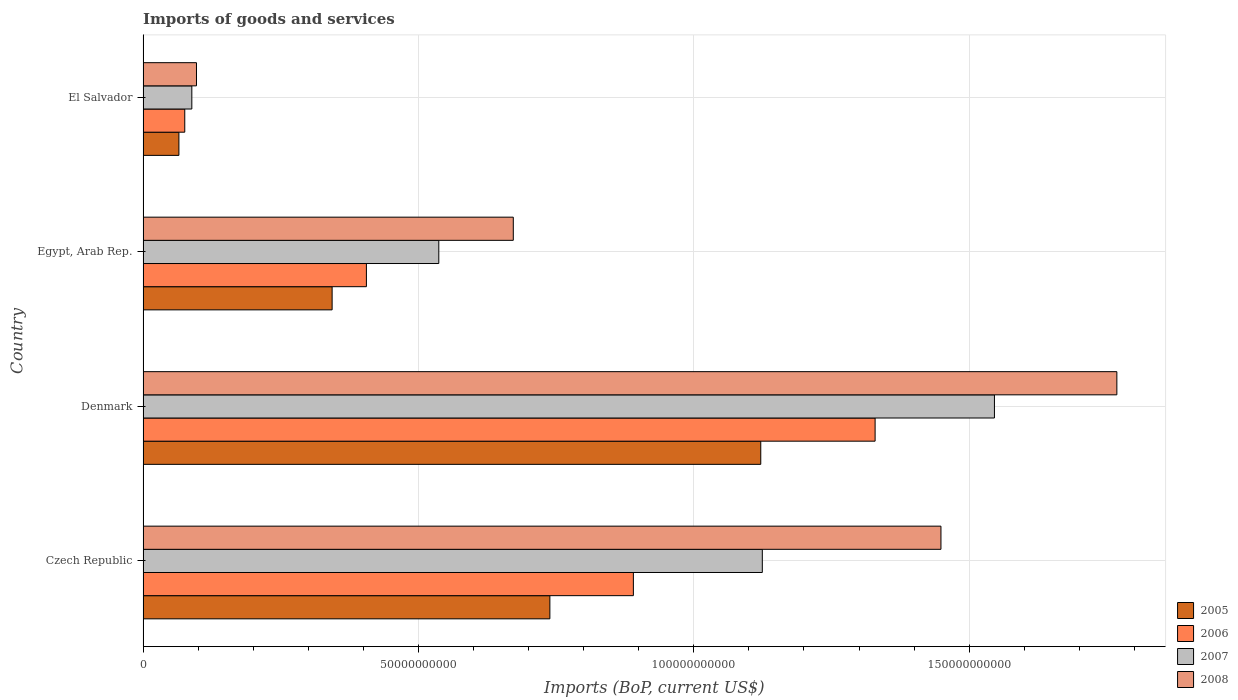How many different coloured bars are there?
Your answer should be compact. 4. Are the number of bars per tick equal to the number of legend labels?
Provide a short and direct response. Yes. Are the number of bars on each tick of the Y-axis equal?
Provide a short and direct response. Yes. How many bars are there on the 4th tick from the top?
Your answer should be compact. 4. How many bars are there on the 4th tick from the bottom?
Ensure brevity in your answer.  4. What is the label of the 1st group of bars from the top?
Give a very brief answer. El Salvador. What is the amount spent on imports in 2008 in Egypt, Arab Rep.?
Ensure brevity in your answer.  6.72e+1. Across all countries, what is the maximum amount spent on imports in 2007?
Your response must be concise. 1.55e+11. Across all countries, what is the minimum amount spent on imports in 2007?
Offer a very short reply. 8.86e+09. In which country was the amount spent on imports in 2008 minimum?
Give a very brief answer. El Salvador. What is the total amount spent on imports in 2006 in the graph?
Offer a very short reply. 2.70e+11. What is the difference between the amount spent on imports in 2007 in Egypt, Arab Rep. and that in El Salvador?
Provide a succinct answer. 4.48e+1. What is the difference between the amount spent on imports in 2007 in Czech Republic and the amount spent on imports in 2008 in Denmark?
Ensure brevity in your answer.  -6.44e+1. What is the average amount spent on imports in 2007 per country?
Provide a short and direct response. 8.24e+1. What is the difference between the amount spent on imports in 2007 and amount spent on imports in 2008 in Czech Republic?
Your answer should be compact. -3.24e+1. In how many countries, is the amount spent on imports in 2006 greater than 160000000000 US$?
Provide a succinct answer. 0. What is the ratio of the amount spent on imports in 2008 in Denmark to that in Egypt, Arab Rep.?
Provide a succinct answer. 2.63. Is the amount spent on imports in 2005 in Czech Republic less than that in Denmark?
Your answer should be compact. Yes. Is the difference between the amount spent on imports in 2007 in Egypt, Arab Rep. and El Salvador greater than the difference between the amount spent on imports in 2008 in Egypt, Arab Rep. and El Salvador?
Provide a succinct answer. No. What is the difference between the highest and the second highest amount spent on imports in 2005?
Your response must be concise. 3.83e+1. What is the difference between the highest and the lowest amount spent on imports in 2007?
Keep it short and to the point. 1.46e+11. In how many countries, is the amount spent on imports in 2006 greater than the average amount spent on imports in 2006 taken over all countries?
Give a very brief answer. 2. Is it the case that in every country, the sum of the amount spent on imports in 2007 and amount spent on imports in 2008 is greater than the sum of amount spent on imports in 2006 and amount spent on imports in 2005?
Ensure brevity in your answer.  No. What does the 2nd bar from the top in Egypt, Arab Rep. represents?
Ensure brevity in your answer.  2007. Is it the case that in every country, the sum of the amount spent on imports in 2006 and amount spent on imports in 2008 is greater than the amount spent on imports in 2005?
Offer a very short reply. Yes. How many bars are there?
Make the answer very short. 16. What is the difference between two consecutive major ticks on the X-axis?
Give a very brief answer. 5.00e+1. Are the values on the major ticks of X-axis written in scientific E-notation?
Ensure brevity in your answer.  No. Does the graph contain any zero values?
Offer a terse response. No. How many legend labels are there?
Keep it short and to the point. 4. What is the title of the graph?
Offer a very short reply. Imports of goods and services. What is the label or title of the X-axis?
Offer a very short reply. Imports (BoP, current US$). What is the label or title of the Y-axis?
Provide a succinct answer. Country. What is the Imports (BoP, current US$) in 2005 in Czech Republic?
Your answer should be compact. 7.39e+1. What is the Imports (BoP, current US$) of 2006 in Czech Republic?
Offer a very short reply. 8.90e+1. What is the Imports (BoP, current US$) in 2007 in Czech Republic?
Give a very brief answer. 1.12e+11. What is the Imports (BoP, current US$) in 2008 in Czech Republic?
Your response must be concise. 1.45e+11. What is the Imports (BoP, current US$) of 2005 in Denmark?
Your answer should be very brief. 1.12e+11. What is the Imports (BoP, current US$) of 2006 in Denmark?
Provide a short and direct response. 1.33e+11. What is the Imports (BoP, current US$) in 2007 in Denmark?
Offer a very short reply. 1.55e+11. What is the Imports (BoP, current US$) of 2008 in Denmark?
Offer a very short reply. 1.77e+11. What is the Imports (BoP, current US$) of 2005 in Egypt, Arab Rep.?
Provide a short and direct response. 3.43e+1. What is the Imports (BoP, current US$) of 2006 in Egypt, Arab Rep.?
Give a very brief answer. 4.06e+1. What is the Imports (BoP, current US$) in 2007 in Egypt, Arab Rep.?
Give a very brief answer. 5.37e+1. What is the Imports (BoP, current US$) of 2008 in Egypt, Arab Rep.?
Ensure brevity in your answer.  6.72e+1. What is the Imports (BoP, current US$) in 2005 in El Salvador?
Ensure brevity in your answer.  6.51e+09. What is the Imports (BoP, current US$) in 2006 in El Salvador?
Ensure brevity in your answer.  7.57e+09. What is the Imports (BoP, current US$) of 2007 in El Salvador?
Provide a succinct answer. 8.86e+09. What is the Imports (BoP, current US$) in 2008 in El Salvador?
Ensure brevity in your answer.  9.70e+09. Across all countries, what is the maximum Imports (BoP, current US$) in 2005?
Ensure brevity in your answer.  1.12e+11. Across all countries, what is the maximum Imports (BoP, current US$) of 2006?
Your response must be concise. 1.33e+11. Across all countries, what is the maximum Imports (BoP, current US$) of 2007?
Keep it short and to the point. 1.55e+11. Across all countries, what is the maximum Imports (BoP, current US$) of 2008?
Give a very brief answer. 1.77e+11. Across all countries, what is the minimum Imports (BoP, current US$) in 2005?
Keep it short and to the point. 6.51e+09. Across all countries, what is the minimum Imports (BoP, current US$) of 2006?
Give a very brief answer. 7.57e+09. Across all countries, what is the minimum Imports (BoP, current US$) in 2007?
Offer a very short reply. 8.86e+09. Across all countries, what is the minimum Imports (BoP, current US$) of 2008?
Make the answer very short. 9.70e+09. What is the total Imports (BoP, current US$) of 2005 in the graph?
Give a very brief answer. 2.27e+11. What is the total Imports (BoP, current US$) in 2006 in the graph?
Your response must be concise. 2.70e+11. What is the total Imports (BoP, current US$) in 2007 in the graph?
Offer a very short reply. 3.30e+11. What is the total Imports (BoP, current US$) in 2008 in the graph?
Your answer should be compact. 3.99e+11. What is the difference between the Imports (BoP, current US$) of 2005 in Czech Republic and that in Denmark?
Ensure brevity in your answer.  -3.83e+1. What is the difference between the Imports (BoP, current US$) in 2006 in Czech Republic and that in Denmark?
Make the answer very short. -4.39e+1. What is the difference between the Imports (BoP, current US$) of 2007 in Czech Republic and that in Denmark?
Your answer should be very brief. -4.21e+1. What is the difference between the Imports (BoP, current US$) in 2008 in Czech Republic and that in Denmark?
Your answer should be very brief. -3.19e+1. What is the difference between the Imports (BoP, current US$) of 2005 in Czech Republic and that in Egypt, Arab Rep.?
Your answer should be very brief. 3.95e+1. What is the difference between the Imports (BoP, current US$) in 2006 in Czech Republic and that in Egypt, Arab Rep.?
Offer a terse response. 4.85e+1. What is the difference between the Imports (BoP, current US$) of 2007 in Czech Republic and that in Egypt, Arab Rep.?
Keep it short and to the point. 5.87e+1. What is the difference between the Imports (BoP, current US$) in 2008 in Czech Republic and that in Egypt, Arab Rep.?
Offer a very short reply. 7.76e+1. What is the difference between the Imports (BoP, current US$) of 2005 in Czech Republic and that in El Salvador?
Provide a short and direct response. 6.74e+1. What is the difference between the Imports (BoP, current US$) in 2006 in Czech Republic and that in El Salvador?
Offer a very short reply. 8.15e+1. What is the difference between the Imports (BoP, current US$) of 2007 in Czech Republic and that in El Salvador?
Your response must be concise. 1.04e+11. What is the difference between the Imports (BoP, current US$) in 2008 in Czech Republic and that in El Salvador?
Offer a terse response. 1.35e+11. What is the difference between the Imports (BoP, current US$) of 2005 in Denmark and that in Egypt, Arab Rep.?
Offer a very short reply. 7.78e+1. What is the difference between the Imports (BoP, current US$) of 2006 in Denmark and that in Egypt, Arab Rep.?
Give a very brief answer. 9.24e+1. What is the difference between the Imports (BoP, current US$) of 2007 in Denmark and that in Egypt, Arab Rep.?
Your answer should be compact. 1.01e+11. What is the difference between the Imports (BoP, current US$) in 2008 in Denmark and that in Egypt, Arab Rep.?
Offer a very short reply. 1.10e+11. What is the difference between the Imports (BoP, current US$) of 2005 in Denmark and that in El Salvador?
Offer a very short reply. 1.06e+11. What is the difference between the Imports (BoP, current US$) in 2006 in Denmark and that in El Salvador?
Ensure brevity in your answer.  1.25e+11. What is the difference between the Imports (BoP, current US$) in 2007 in Denmark and that in El Salvador?
Offer a very short reply. 1.46e+11. What is the difference between the Imports (BoP, current US$) of 2008 in Denmark and that in El Salvador?
Offer a very short reply. 1.67e+11. What is the difference between the Imports (BoP, current US$) in 2005 in Egypt, Arab Rep. and that in El Salvador?
Ensure brevity in your answer.  2.78e+1. What is the difference between the Imports (BoP, current US$) in 2006 in Egypt, Arab Rep. and that in El Salvador?
Your answer should be compact. 3.30e+1. What is the difference between the Imports (BoP, current US$) in 2007 in Egypt, Arab Rep. and that in El Salvador?
Make the answer very short. 4.48e+1. What is the difference between the Imports (BoP, current US$) of 2008 in Egypt, Arab Rep. and that in El Salvador?
Make the answer very short. 5.75e+1. What is the difference between the Imports (BoP, current US$) of 2005 in Czech Republic and the Imports (BoP, current US$) of 2006 in Denmark?
Your answer should be very brief. -5.91e+1. What is the difference between the Imports (BoP, current US$) in 2005 in Czech Republic and the Imports (BoP, current US$) in 2007 in Denmark?
Offer a terse response. -8.07e+1. What is the difference between the Imports (BoP, current US$) of 2005 in Czech Republic and the Imports (BoP, current US$) of 2008 in Denmark?
Make the answer very short. -1.03e+11. What is the difference between the Imports (BoP, current US$) in 2006 in Czech Republic and the Imports (BoP, current US$) in 2007 in Denmark?
Provide a succinct answer. -6.56e+1. What is the difference between the Imports (BoP, current US$) in 2006 in Czech Republic and the Imports (BoP, current US$) in 2008 in Denmark?
Make the answer very short. -8.78e+1. What is the difference between the Imports (BoP, current US$) in 2007 in Czech Republic and the Imports (BoP, current US$) in 2008 in Denmark?
Make the answer very short. -6.44e+1. What is the difference between the Imports (BoP, current US$) of 2005 in Czech Republic and the Imports (BoP, current US$) of 2006 in Egypt, Arab Rep.?
Your answer should be compact. 3.33e+1. What is the difference between the Imports (BoP, current US$) of 2005 in Czech Republic and the Imports (BoP, current US$) of 2007 in Egypt, Arab Rep.?
Your response must be concise. 2.02e+1. What is the difference between the Imports (BoP, current US$) of 2005 in Czech Republic and the Imports (BoP, current US$) of 2008 in Egypt, Arab Rep.?
Provide a succinct answer. 6.64e+09. What is the difference between the Imports (BoP, current US$) in 2006 in Czech Republic and the Imports (BoP, current US$) in 2007 in Egypt, Arab Rep.?
Provide a succinct answer. 3.53e+1. What is the difference between the Imports (BoP, current US$) in 2006 in Czech Republic and the Imports (BoP, current US$) in 2008 in Egypt, Arab Rep.?
Ensure brevity in your answer.  2.18e+1. What is the difference between the Imports (BoP, current US$) in 2007 in Czech Republic and the Imports (BoP, current US$) in 2008 in Egypt, Arab Rep.?
Give a very brief answer. 4.52e+1. What is the difference between the Imports (BoP, current US$) in 2005 in Czech Republic and the Imports (BoP, current US$) in 2006 in El Salvador?
Keep it short and to the point. 6.63e+1. What is the difference between the Imports (BoP, current US$) of 2005 in Czech Republic and the Imports (BoP, current US$) of 2007 in El Salvador?
Your answer should be compact. 6.50e+1. What is the difference between the Imports (BoP, current US$) in 2005 in Czech Republic and the Imports (BoP, current US$) in 2008 in El Salvador?
Your answer should be compact. 6.42e+1. What is the difference between the Imports (BoP, current US$) of 2006 in Czech Republic and the Imports (BoP, current US$) of 2007 in El Salvador?
Your response must be concise. 8.02e+1. What is the difference between the Imports (BoP, current US$) of 2006 in Czech Republic and the Imports (BoP, current US$) of 2008 in El Salvador?
Offer a terse response. 7.93e+1. What is the difference between the Imports (BoP, current US$) of 2007 in Czech Republic and the Imports (BoP, current US$) of 2008 in El Salvador?
Your answer should be very brief. 1.03e+11. What is the difference between the Imports (BoP, current US$) in 2005 in Denmark and the Imports (BoP, current US$) in 2006 in Egypt, Arab Rep.?
Give a very brief answer. 7.16e+1. What is the difference between the Imports (BoP, current US$) in 2005 in Denmark and the Imports (BoP, current US$) in 2007 in Egypt, Arab Rep.?
Offer a very short reply. 5.85e+1. What is the difference between the Imports (BoP, current US$) in 2005 in Denmark and the Imports (BoP, current US$) in 2008 in Egypt, Arab Rep.?
Provide a short and direct response. 4.49e+1. What is the difference between the Imports (BoP, current US$) of 2006 in Denmark and the Imports (BoP, current US$) of 2007 in Egypt, Arab Rep.?
Provide a short and direct response. 7.92e+1. What is the difference between the Imports (BoP, current US$) of 2006 in Denmark and the Imports (BoP, current US$) of 2008 in Egypt, Arab Rep.?
Provide a short and direct response. 6.57e+1. What is the difference between the Imports (BoP, current US$) in 2007 in Denmark and the Imports (BoP, current US$) in 2008 in Egypt, Arab Rep.?
Offer a terse response. 8.74e+1. What is the difference between the Imports (BoP, current US$) of 2005 in Denmark and the Imports (BoP, current US$) of 2006 in El Salvador?
Provide a succinct answer. 1.05e+11. What is the difference between the Imports (BoP, current US$) of 2005 in Denmark and the Imports (BoP, current US$) of 2007 in El Salvador?
Provide a short and direct response. 1.03e+11. What is the difference between the Imports (BoP, current US$) of 2005 in Denmark and the Imports (BoP, current US$) of 2008 in El Salvador?
Offer a terse response. 1.02e+11. What is the difference between the Imports (BoP, current US$) of 2006 in Denmark and the Imports (BoP, current US$) of 2007 in El Salvador?
Make the answer very short. 1.24e+11. What is the difference between the Imports (BoP, current US$) of 2006 in Denmark and the Imports (BoP, current US$) of 2008 in El Salvador?
Keep it short and to the point. 1.23e+11. What is the difference between the Imports (BoP, current US$) of 2007 in Denmark and the Imports (BoP, current US$) of 2008 in El Salvador?
Your answer should be very brief. 1.45e+11. What is the difference between the Imports (BoP, current US$) of 2005 in Egypt, Arab Rep. and the Imports (BoP, current US$) of 2006 in El Salvador?
Your answer should be very brief. 2.68e+1. What is the difference between the Imports (BoP, current US$) of 2005 in Egypt, Arab Rep. and the Imports (BoP, current US$) of 2007 in El Salvador?
Provide a succinct answer. 2.55e+1. What is the difference between the Imports (BoP, current US$) in 2005 in Egypt, Arab Rep. and the Imports (BoP, current US$) in 2008 in El Salvador?
Offer a very short reply. 2.46e+1. What is the difference between the Imports (BoP, current US$) of 2006 in Egypt, Arab Rep. and the Imports (BoP, current US$) of 2007 in El Salvador?
Ensure brevity in your answer.  3.17e+1. What is the difference between the Imports (BoP, current US$) in 2006 in Egypt, Arab Rep. and the Imports (BoP, current US$) in 2008 in El Salvador?
Offer a very short reply. 3.09e+1. What is the difference between the Imports (BoP, current US$) of 2007 in Egypt, Arab Rep. and the Imports (BoP, current US$) of 2008 in El Salvador?
Provide a short and direct response. 4.40e+1. What is the average Imports (BoP, current US$) in 2005 per country?
Provide a succinct answer. 5.67e+1. What is the average Imports (BoP, current US$) in 2006 per country?
Make the answer very short. 6.75e+1. What is the average Imports (BoP, current US$) of 2007 per country?
Your answer should be compact. 8.24e+1. What is the average Imports (BoP, current US$) of 2008 per country?
Offer a terse response. 9.97e+1. What is the difference between the Imports (BoP, current US$) of 2005 and Imports (BoP, current US$) of 2006 in Czech Republic?
Your answer should be very brief. -1.52e+1. What is the difference between the Imports (BoP, current US$) in 2005 and Imports (BoP, current US$) in 2007 in Czech Republic?
Give a very brief answer. -3.86e+1. What is the difference between the Imports (BoP, current US$) of 2005 and Imports (BoP, current US$) of 2008 in Czech Republic?
Offer a terse response. -7.10e+1. What is the difference between the Imports (BoP, current US$) in 2006 and Imports (BoP, current US$) in 2007 in Czech Republic?
Your answer should be compact. -2.34e+1. What is the difference between the Imports (BoP, current US$) of 2006 and Imports (BoP, current US$) of 2008 in Czech Republic?
Keep it short and to the point. -5.58e+1. What is the difference between the Imports (BoP, current US$) in 2007 and Imports (BoP, current US$) in 2008 in Czech Republic?
Provide a short and direct response. -3.24e+1. What is the difference between the Imports (BoP, current US$) in 2005 and Imports (BoP, current US$) in 2006 in Denmark?
Your response must be concise. -2.08e+1. What is the difference between the Imports (BoP, current US$) in 2005 and Imports (BoP, current US$) in 2007 in Denmark?
Offer a very short reply. -4.24e+1. What is the difference between the Imports (BoP, current US$) of 2005 and Imports (BoP, current US$) of 2008 in Denmark?
Ensure brevity in your answer.  -6.47e+1. What is the difference between the Imports (BoP, current US$) in 2006 and Imports (BoP, current US$) in 2007 in Denmark?
Keep it short and to the point. -2.17e+1. What is the difference between the Imports (BoP, current US$) in 2006 and Imports (BoP, current US$) in 2008 in Denmark?
Your answer should be compact. -4.39e+1. What is the difference between the Imports (BoP, current US$) of 2007 and Imports (BoP, current US$) of 2008 in Denmark?
Keep it short and to the point. -2.22e+1. What is the difference between the Imports (BoP, current US$) in 2005 and Imports (BoP, current US$) in 2006 in Egypt, Arab Rep.?
Keep it short and to the point. -6.23e+09. What is the difference between the Imports (BoP, current US$) in 2005 and Imports (BoP, current US$) in 2007 in Egypt, Arab Rep.?
Provide a succinct answer. -1.94e+1. What is the difference between the Imports (BoP, current US$) in 2005 and Imports (BoP, current US$) in 2008 in Egypt, Arab Rep.?
Offer a terse response. -3.29e+1. What is the difference between the Imports (BoP, current US$) in 2006 and Imports (BoP, current US$) in 2007 in Egypt, Arab Rep.?
Ensure brevity in your answer.  -1.31e+1. What is the difference between the Imports (BoP, current US$) of 2006 and Imports (BoP, current US$) of 2008 in Egypt, Arab Rep.?
Make the answer very short. -2.67e+1. What is the difference between the Imports (BoP, current US$) in 2007 and Imports (BoP, current US$) in 2008 in Egypt, Arab Rep.?
Offer a very short reply. -1.35e+1. What is the difference between the Imports (BoP, current US$) of 2005 and Imports (BoP, current US$) of 2006 in El Salvador?
Give a very brief answer. -1.06e+09. What is the difference between the Imports (BoP, current US$) in 2005 and Imports (BoP, current US$) in 2007 in El Salvador?
Ensure brevity in your answer.  -2.35e+09. What is the difference between the Imports (BoP, current US$) in 2005 and Imports (BoP, current US$) in 2008 in El Salvador?
Your response must be concise. -3.19e+09. What is the difference between the Imports (BoP, current US$) in 2006 and Imports (BoP, current US$) in 2007 in El Salvador?
Your response must be concise. -1.28e+09. What is the difference between the Imports (BoP, current US$) of 2006 and Imports (BoP, current US$) of 2008 in El Salvador?
Provide a short and direct response. -2.13e+09. What is the difference between the Imports (BoP, current US$) of 2007 and Imports (BoP, current US$) of 2008 in El Salvador?
Offer a terse response. -8.44e+08. What is the ratio of the Imports (BoP, current US$) of 2005 in Czech Republic to that in Denmark?
Ensure brevity in your answer.  0.66. What is the ratio of the Imports (BoP, current US$) of 2006 in Czech Republic to that in Denmark?
Your response must be concise. 0.67. What is the ratio of the Imports (BoP, current US$) in 2007 in Czech Republic to that in Denmark?
Ensure brevity in your answer.  0.73. What is the ratio of the Imports (BoP, current US$) of 2008 in Czech Republic to that in Denmark?
Your response must be concise. 0.82. What is the ratio of the Imports (BoP, current US$) in 2005 in Czech Republic to that in Egypt, Arab Rep.?
Your response must be concise. 2.15. What is the ratio of the Imports (BoP, current US$) in 2006 in Czech Republic to that in Egypt, Arab Rep.?
Offer a very short reply. 2.2. What is the ratio of the Imports (BoP, current US$) of 2007 in Czech Republic to that in Egypt, Arab Rep.?
Your answer should be compact. 2.09. What is the ratio of the Imports (BoP, current US$) in 2008 in Czech Republic to that in Egypt, Arab Rep.?
Give a very brief answer. 2.16. What is the ratio of the Imports (BoP, current US$) in 2005 in Czech Republic to that in El Salvador?
Ensure brevity in your answer.  11.35. What is the ratio of the Imports (BoP, current US$) of 2006 in Czech Republic to that in El Salvador?
Provide a short and direct response. 11.76. What is the ratio of the Imports (BoP, current US$) in 2007 in Czech Republic to that in El Salvador?
Your response must be concise. 12.7. What is the ratio of the Imports (BoP, current US$) of 2008 in Czech Republic to that in El Salvador?
Make the answer very short. 14.94. What is the ratio of the Imports (BoP, current US$) in 2005 in Denmark to that in Egypt, Arab Rep.?
Make the answer very short. 3.27. What is the ratio of the Imports (BoP, current US$) of 2006 in Denmark to that in Egypt, Arab Rep.?
Your answer should be very brief. 3.28. What is the ratio of the Imports (BoP, current US$) of 2007 in Denmark to that in Egypt, Arab Rep.?
Your answer should be very brief. 2.88. What is the ratio of the Imports (BoP, current US$) in 2008 in Denmark to that in Egypt, Arab Rep.?
Provide a succinct answer. 2.63. What is the ratio of the Imports (BoP, current US$) in 2005 in Denmark to that in El Salvador?
Ensure brevity in your answer.  17.23. What is the ratio of the Imports (BoP, current US$) in 2006 in Denmark to that in El Salvador?
Make the answer very short. 17.56. What is the ratio of the Imports (BoP, current US$) of 2007 in Denmark to that in El Salvador?
Ensure brevity in your answer.  17.46. What is the ratio of the Imports (BoP, current US$) in 2008 in Denmark to that in El Salvador?
Your response must be concise. 18.23. What is the ratio of the Imports (BoP, current US$) in 2005 in Egypt, Arab Rep. to that in El Salvador?
Offer a terse response. 5.27. What is the ratio of the Imports (BoP, current US$) of 2006 in Egypt, Arab Rep. to that in El Salvador?
Provide a succinct answer. 5.36. What is the ratio of the Imports (BoP, current US$) of 2007 in Egypt, Arab Rep. to that in El Salvador?
Offer a very short reply. 6.06. What is the ratio of the Imports (BoP, current US$) in 2008 in Egypt, Arab Rep. to that in El Salvador?
Give a very brief answer. 6.93. What is the difference between the highest and the second highest Imports (BoP, current US$) of 2005?
Keep it short and to the point. 3.83e+1. What is the difference between the highest and the second highest Imports (BoP, current US$) in 2006?
Give a very brief answer. 4.39e+1. What is the difference between the highest and the second highest Imports (BoP, current US$) in 2007?
Provide a succinct answer. 4.21e+1. What is the difference between the highest and the second highest Imports (BoP, current US$) of 2008?
Your answer should be very brief. 3.19e+1. What is the difference between the highest and the lowest Imports (BoP, current US$) of 2005?
Keep it short and to the point. 1.06e+11. What is the difference between the highest and the lowest Imports (BoP, current US$) of 2006?
Provide a short and direct response. 1.25e+11. What is the difference between the highest and the lowest Imports (BoP, current US$) in 2007?
Offer a terse response. 1.46e+11. What is the difference between the highest and the lowest Imports (BoP, current US$) in 2008?
Give a very brief answer. 1.67e+11. 